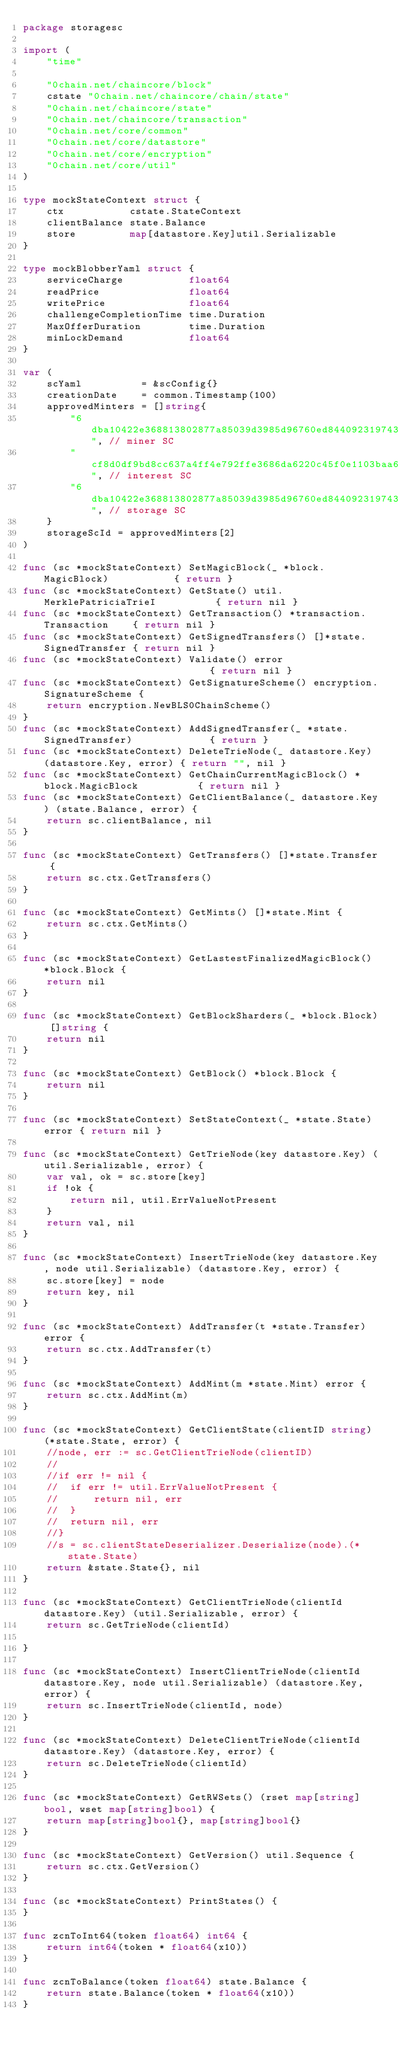Convert code to text. <code><loc_0><loc_0><loc_500><loc_500><_Go_>package storagesc

import (
	"time"

	"0chain.net/chaincore/block"
	cstate "0chain.net/chaincore/chain/state"
	"0chain.net/chaincore/state"
	"0chain.net/chaincore/transaction"
	"0chain.net/core/common"
	"0chain.net/core/datastore"
	"0chain.net/core/encryption"
	"0chain.net/core/util"
)

type mockStateContext struct {
	ctx           cstate.StateContext
	clientBalance state.Balance
	store         map[datastore.Key]util.Serializable
}

type mockBlobberYaml struct {
	serviceCharge           float64
	readPrice               float64
	writePrice              float64
	challengeCompletionTime time.Duration
	MaxOfferDuration        time.Duration
	minLockDemand           float64
}

var (
	scYaml          = &scConfig{}
	creationDate    = common.Timestamp(100)
	approvedMinters = []string{
		"6dba10422e368813802877a85039d3985d96760ed844092319743fb3a76712d9", // miner SC
		"cf8d0df9bd8cc637a4ff4e792ffe3686da6220c45f0e1103baa609f3f1751ef4", // interest SC
		"6dba10422e368813802877a85039d3985d96760ed844092319743fb3a76712d7", // storage SC
	}
	storageScId = approvedMinters[2]
)

func (sc *mockStateContext) SetMagicBlock(_ *block.MagicBlock)           { return }
func (sc *mockStateContext) GetState() util.MerklePatriciaTrieI          { return nil }
func (sc *mockStateContext) GetTransaction() *transaction.Transaction    { return nil }
func (sc *mockStateContext) GetSignedTransfers() []*state.SignedTransfer { return nil }
func (sc *mockStateContext) Validate() error                             { return nil }
func (sc *mockStateContext) GetSignatureScheme() encryption.SignatureScheme {
	return encryption.NewBLS0ChainScheme()
}
func (sc *mockStateContext) AddSignedTransfer(_ *state.SignedTransfer)             { return }
func (sc *mockStateContext) DeleteTrieNode(_ datastore.Key) (datastore.Key, error) { return "", nil }
func (sc *mockStateContext) GetChainCurrentMagicBlock() *block.MagicBlock          { return nil }
func (sc *mockStateContext) GetClientBalance(_ datastore.Key) (state.Balance, error) {
	return sc.clientBalance, nil
}

func (sc *mockStateContext) GetTransfers() []*state.Transfer {
	return sc.ctx.GetTransfers()
}

func (sc *mockStateContext) GetMints() []*state.Mint {
	return sc.ctx.GetMints()
}

func (sc *mockStateContext) GetLastestFinalizedMagicBlock() *block.Block {
	return nil
}

func (sc *mockStateContext) GetBlockSharders(_ *block.Block) []string {
	return nil
}

func (sc *mockStateContext) GetBlock() *block.Block {
	return nil
}

func (sc *mockStateContext) SetStateContext(_ *state.State) error { return nil }

func (sc *mockStateContext) GetTrieNode(key datastore.Key) (util.Serializable, error) {
	var val, ok = sc.store[key]
	if !ok {
		return nil, util.ErrValueNotPresent
	}
	return val, nil
}

func (sc *mockStateContext) InsertTrieNode(key datastore.Key, node util.Serializable) (datastore.Key, error) {
	sc.store[key] = node
	return key, nil
}

func (sc *mockStateContext) AddTransfer(t *state.Transfer) error {
	return sc.ctx.AddTransfer(t)
}

func (sc *mockStateContext) AddMint(m *state.Mint) error {
	return sc.ctx.AddMint(m)
}

func (sc *mockStateContext) GetClientState(clientID string) (*state.State, error) {
	//node, err := sc.GetClientTrieNode(clientID)
	//
	//if err != nil {
	//	if err != util.ErrValueNotPresent {
	//		return nil, err
	//	}
	//	return nil, err
	//}
	//s = sc.clientStateDeserializer.Deserialize(node).(*state.State)
	return &state.State{}, nil
}

func (sc *mockStateContext) GetClientTrieNode(clientId datastore.Key) (util.Serializable, error) {
	return sc.GetTrieNode(clientId)

}

func (sc *mockStateContext) InsertClientTrieNode(clientId datastore.Key, node util.Serializable) (datastore.Key, error) {
	return sc.InsertTrieNode(clientId, node)
}

func (sc *mockStateContext) DeleteClientTrieNode(clientId datastore.Key) (datastore.Key, error) {
	return sc.DeleteTrieNode(clientId)
}

func (sc *mockStateContext) GetRWSets() (rset map[string]bool, wset map[string]bool) {
	return map[string]bool{}, map[string]bool{}
}

func (sc *mockStateContext) GetVersion() util.Sequence {
	return sc.ctx.GetVersion()
}

func (sc *mockStateContext) PrintStates() {
}

func zcnToInt64(token float64) int64 {
	return int64(token * float64(x10))
}

func zcnToBalance(token float64) state.Balance {
	return state.Balance(token * float64(x10))
}
</code> 